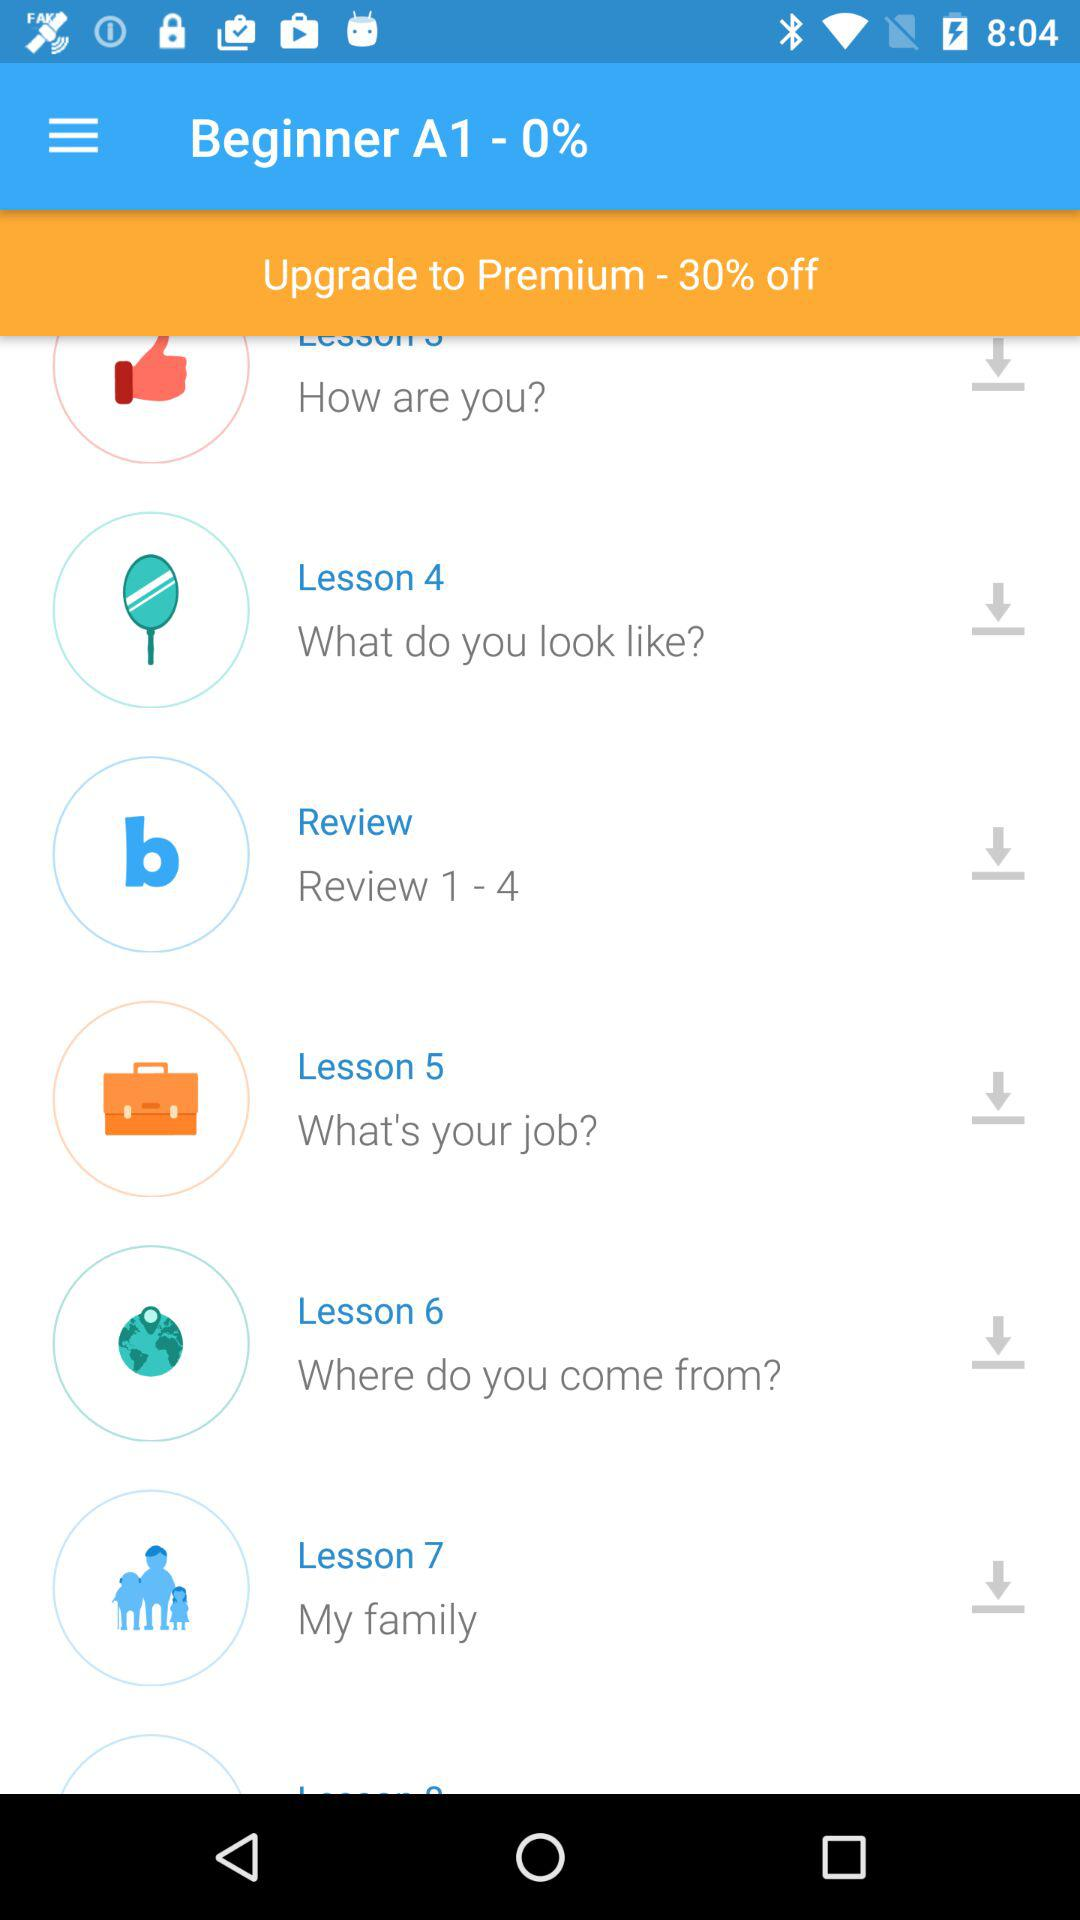What lesson will tell about "Review 1-4"? The lesson is "Review". 